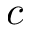<formula> <loc_0><loc_0><loc_500><loc_500>c</formula> 